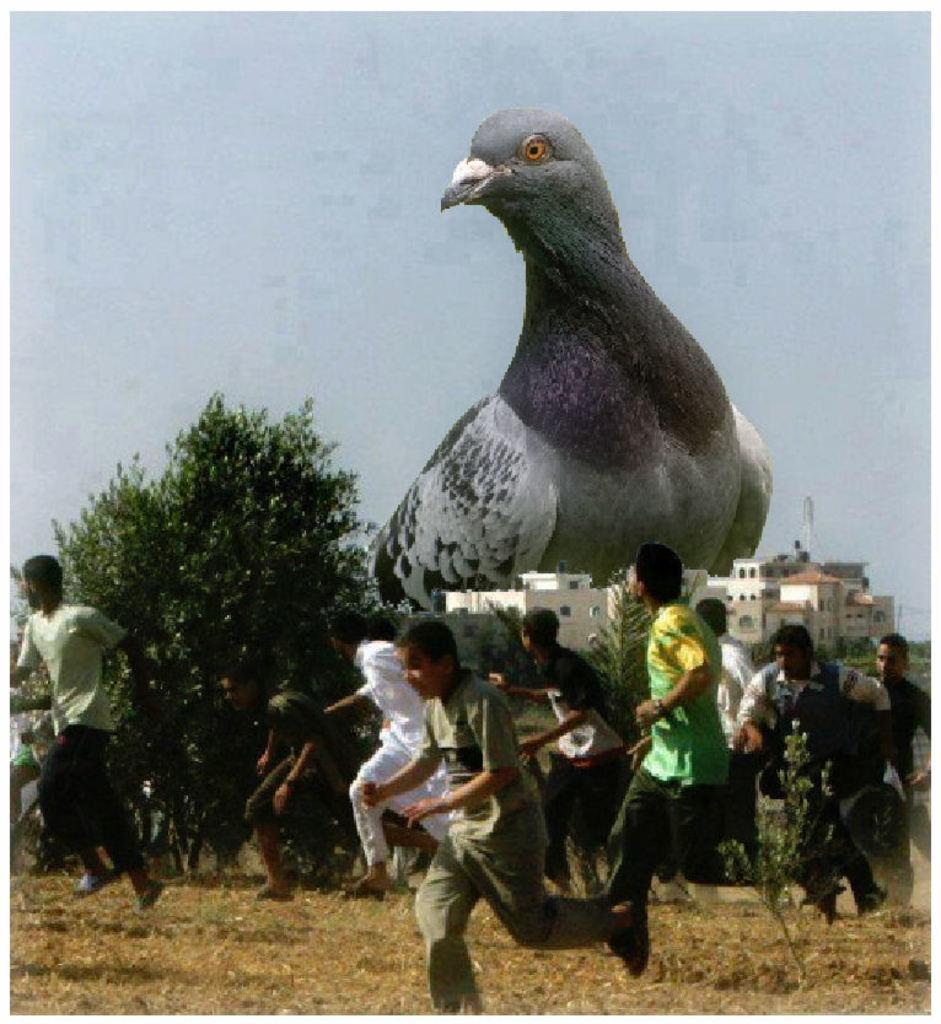What are the persons in the image doing? The persons in the image are running. What structures can be seen in the background of the image? There are buildings visible in the image. What type of vegetation is present in the image? There are trees in the image. What type of animal can be seen in the image? There is a bird in the image. What is visible in the sky in the image? The sky is visible in the image. What type of brain can be seen in the image? There is no brain present in the image. What type of blade is being used by the persons running in the image? The persons running in the image are not using any blades. 